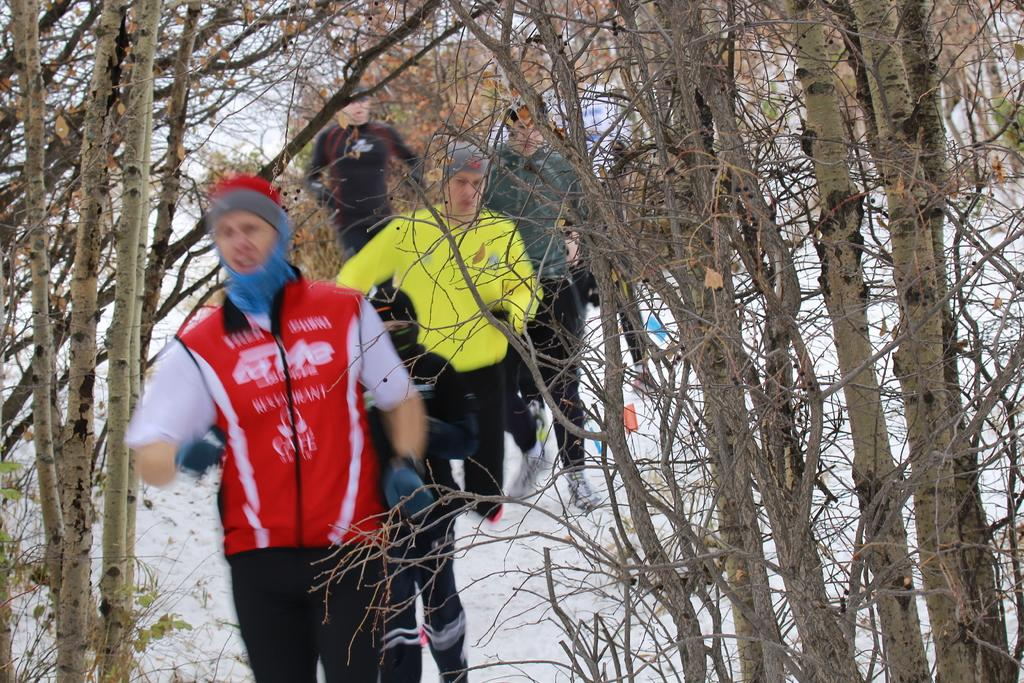What is the primary feature of the landscape in the image? There are many trees in the image. What is the weather like in the image? There is snow visible in the image, indicating a cold and likely wintery scene. Are there any people present in the image? Yes, there are people in the image. What type of bead is being used to create shade for the people in the image? There is no bead present in the image, nor is there any indication that the people are using beads for shade. 